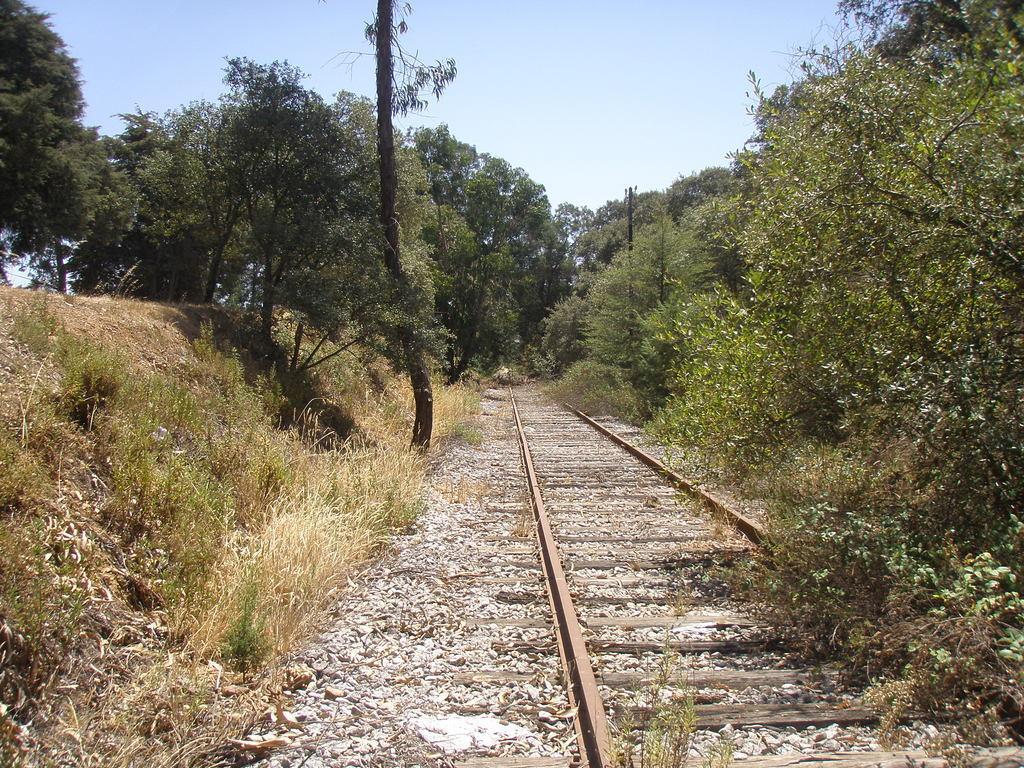How would you summarize this image in a sentence or two? In the background we can see the sky. In this picture we can see a railway track, plants, grass and the trees. 